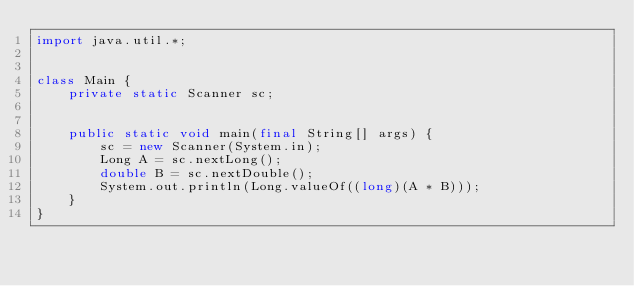Convert code to text. <code><loc_0><loc_0><loc_500><loc_500><_Java_>import java.util.*;


class Main {
    private static Scanner sc;


    public static void main(final String[] args) {
        sc = new Scanner(System.in);
        Long A = sc.nextLong();
        double B = sc.nextDouble();
        System.out.println(Long.valueOf((long)(A * B)));
    }
}






</code> 